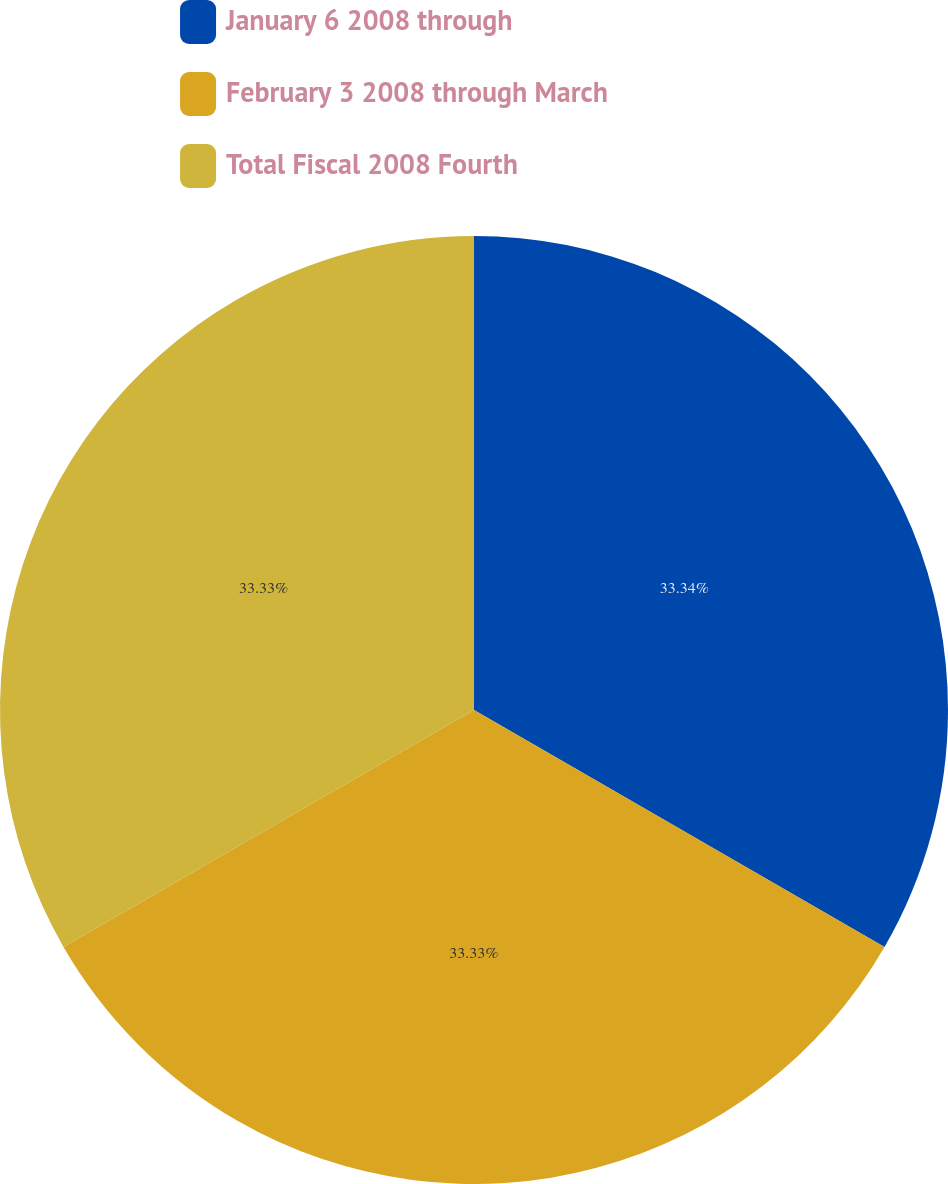Convert chart to OTSL. <chart><loc_0><loc_0><loc_500><loc_500><pie_chart><fcel>January 6 2008 through<fcel>February 3 2008 through March<fcel>Total Fiscal 2008 Fourth<nl><fcel>33.33%<fcel>33.33%<fcel>33.33%<nl></chart> 